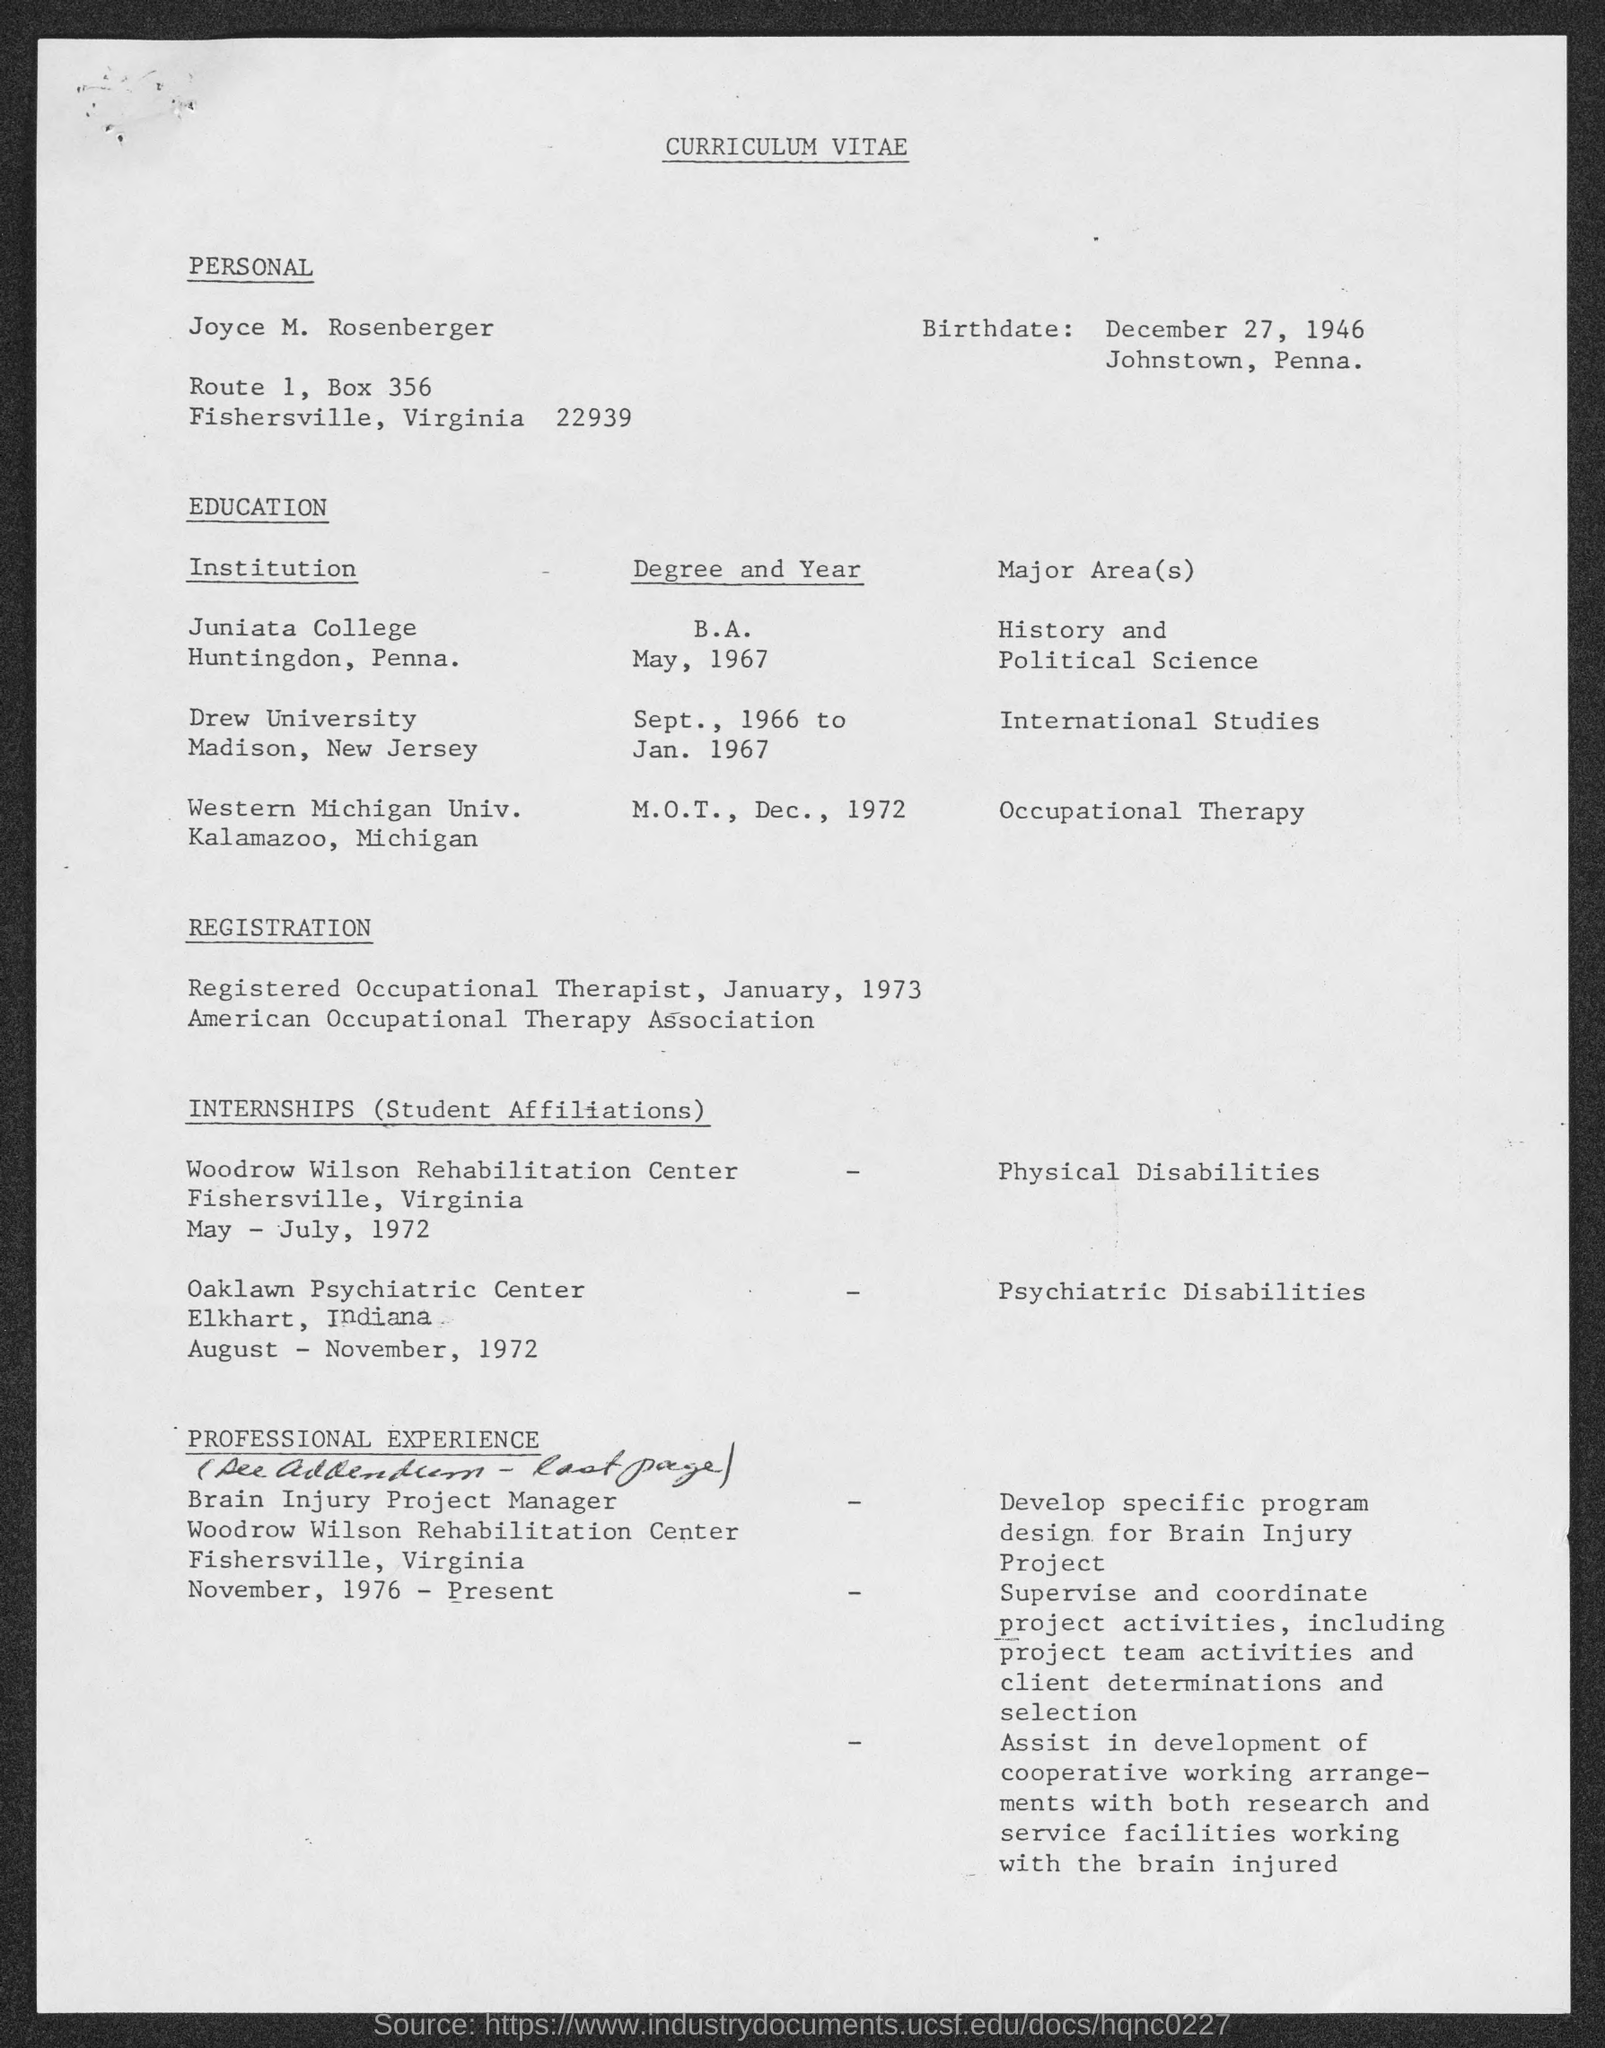Specify some key components in this picture. The birthdate is December 27, 1946. 